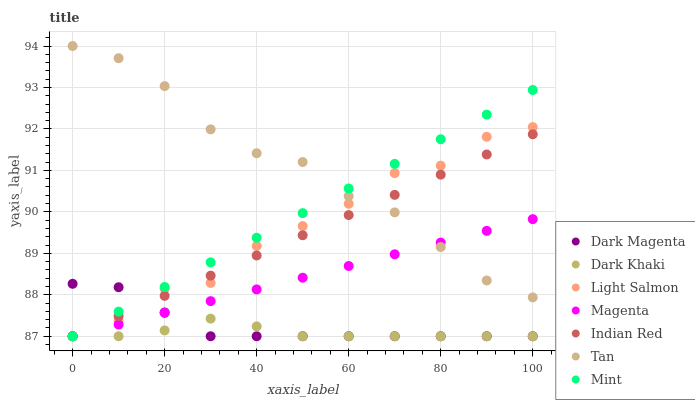Does Dark Khaki have the minimum area under the curve?
Answer yes or no. Yes. Does Tan have the maximum area under the curve?
Answer yes or no. Yes. Does Dark Magenta have the minimum area under the curve?
Answer yes or no. No. Does Dark Magenta have the maximum area under the curve?
Answer yes or no. No. Is Magenta the smoothest?
Answer yes or no. Yes. Is Light Salmon the roughest?
Answer yes or no. Yes. Is Dark Magenta the smoothest?
Answer yes or no. No. Is Dark Magenta the roughest?
Answer yes or no. No. Does Light Salmon have the lowest value?
Answer yes or no. Yes. Does Tan have the lowest value?
Answer yes or no. No. Does Tan have the highest value?
Answer yes or no. Yes. Does Dark Magenta have the highest value?
Answer yes or no. No. Is Dark Magenta less than Tan?
Answer yes or no. Yes. Is Tan greater than Dark Khaki?
Answer yes or no. Yes. Does Dark Magenta intersect Dark Khaki?
Answer yes or no. Yes. Is Dark Magenta less than Dark Khaki?
Answer yes or no. No. Is Dark Magenta greater than Dark Khaki?
Answer yes or no. No. Does Dark Magenta intersect Tan?
Answer yes or no. No. 